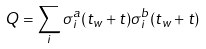<formula> <loc_0><loc_0><loc_500><loc_500>Q = \sum _ { i } \sigma _ { i } ^ { a } ( t _ { w } + t ) \sigma _ { i } ^ { b } ( t _ { w } + t )</formula> 